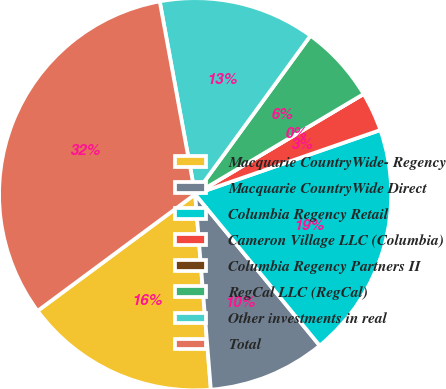<chart> <loc_0><loc_0><loc_500><loc_500><pie_chart><fcel>Macquarie CountryWide- Regency<fcel>Macquarie CountryWide Direct<fcel>Columbia Regency Retail<fcel>Cameron Village LLC (Columbia)<fcel>Columbia Regency Partners II<fcel>RegCal LLC (RegCal)<fcel>Other investments in real<fcel>Total<nl><fcel>16.13%<fcel>9.68%<fcel>19.35%<fcel>3.23%<fcel>0.0%<fcel>6.45%<fcel>12.9%<fcel>32.25%<nl></chart> 